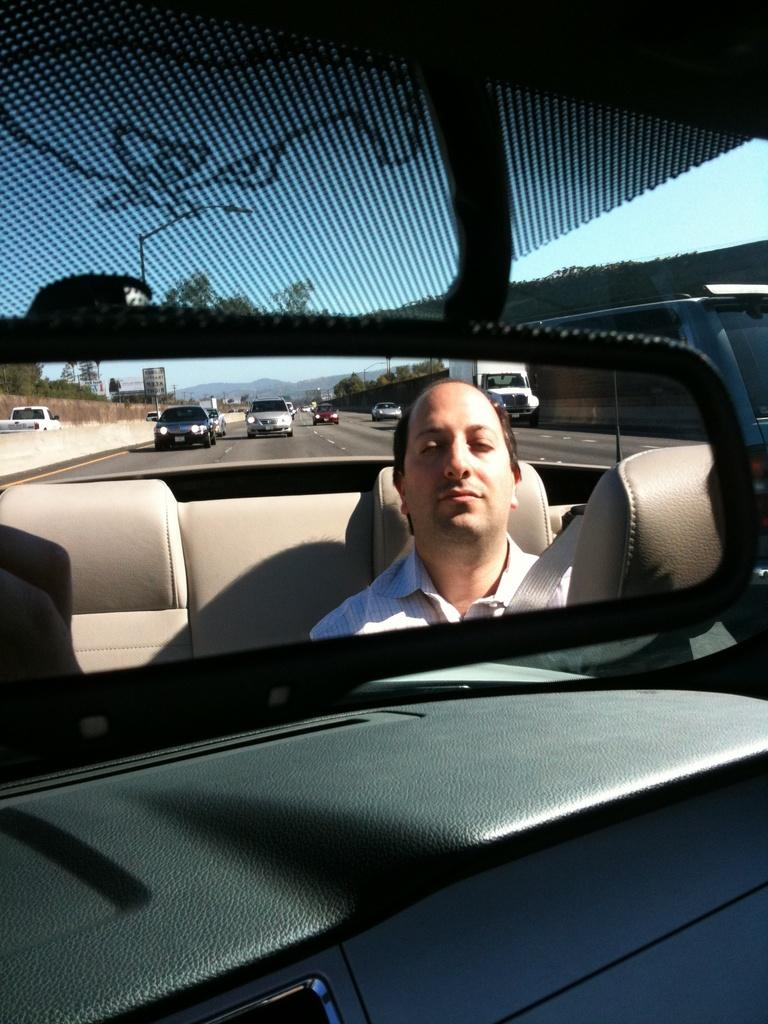What is the main subject of the image? The main subject of the image is a person driving a car. Where is the car located in the image? The car is on the road in the image. How many cars can be seen in the image? There are many cars on the road in the image. What is the condition of the sky in the image? The sky is clear in the image. What type of pies are being sold at the car wash in the image? There is no car wash or pies present in the image; it features a person driving a car on the road. What color is the polish used on the clock in the image? There is no clock or polish present in the image. 